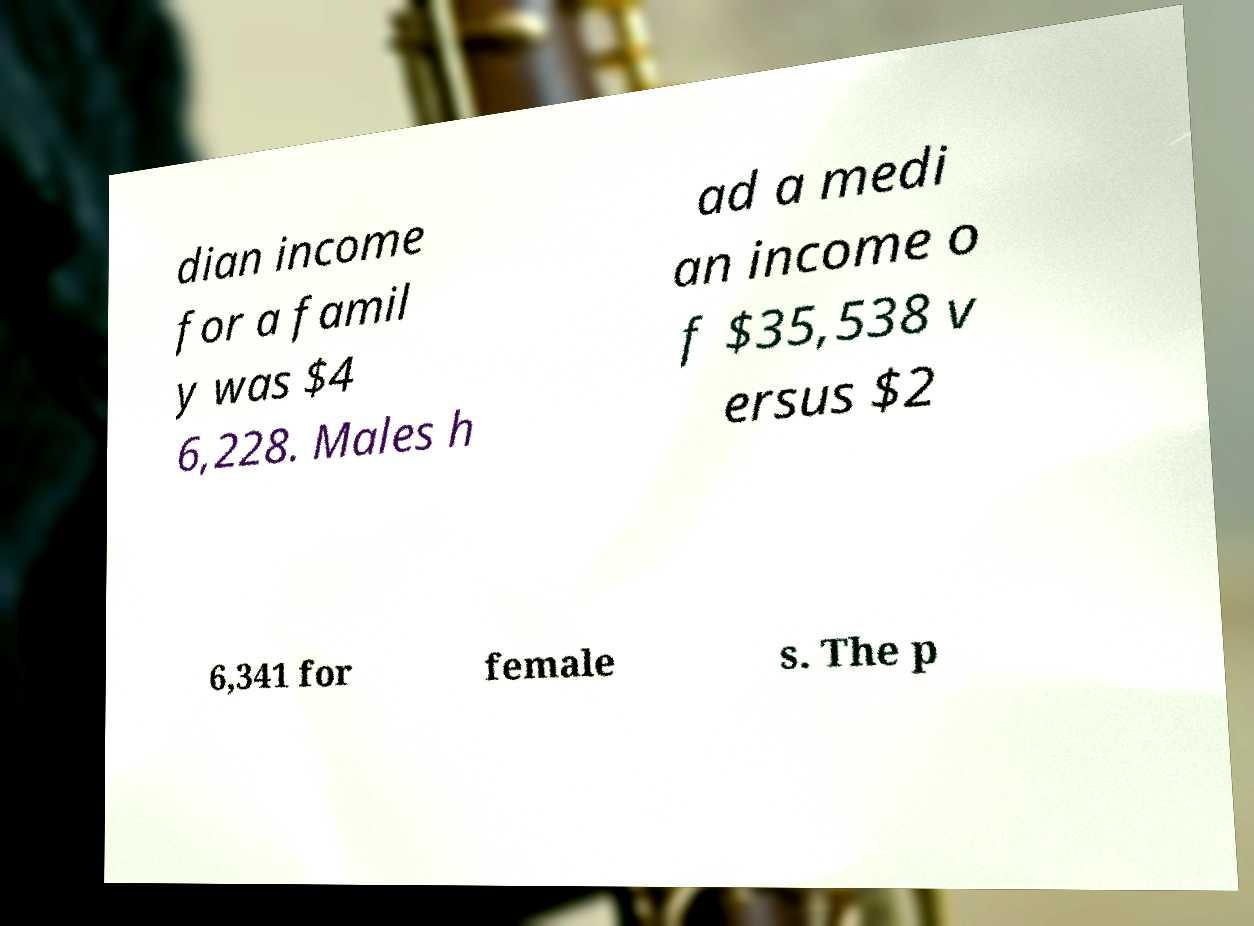Can you read and provide the text displayed in the image?This photo seems to have some interesting text. Can you extract and type it out for me? dian income for a famil y was $4 6,228. Males h ad a medi an income o f $35,538 v ersus $2 6,341 for female s. The p 